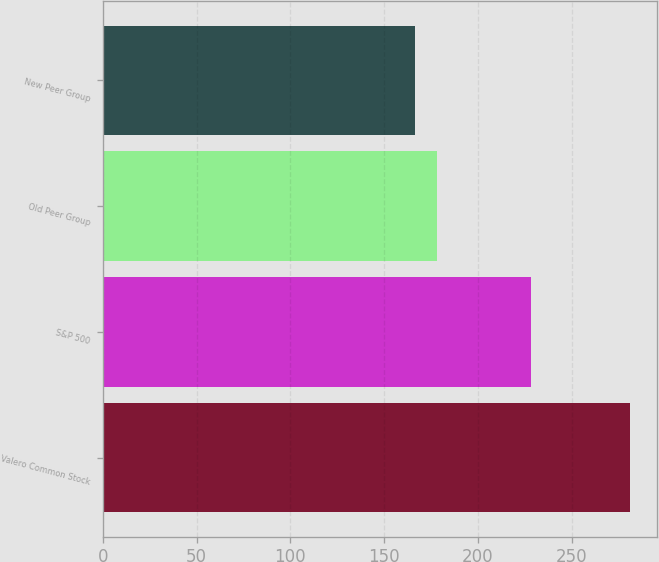Convert chart. <chart><loc_0><loc_0><loc_500><loc_500><bar_chart><fcel>Valero Common Stock<fcel>S&P 500<fcel>Old Peer Group<fcel>New Peer Group<nl><fcel>281.24<fcel>228.19<fcel>178.04<fcel>166.57<nl></chart> 